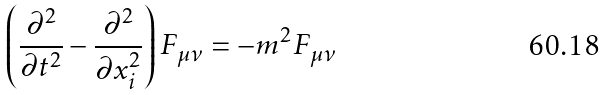<formula> <loc_0><loc_0><loc_500><loc_500>\left ( \frac { \partial ^ { 2 } } { \partial t ^ { 2 } } - \frac { \partial ^ { 2 } } { \partial x _ { i } ^ { 2 } } \right ) F _ { \mu \nu } = - m ^ { 2 } F _ { \mu \nu }</formula> 